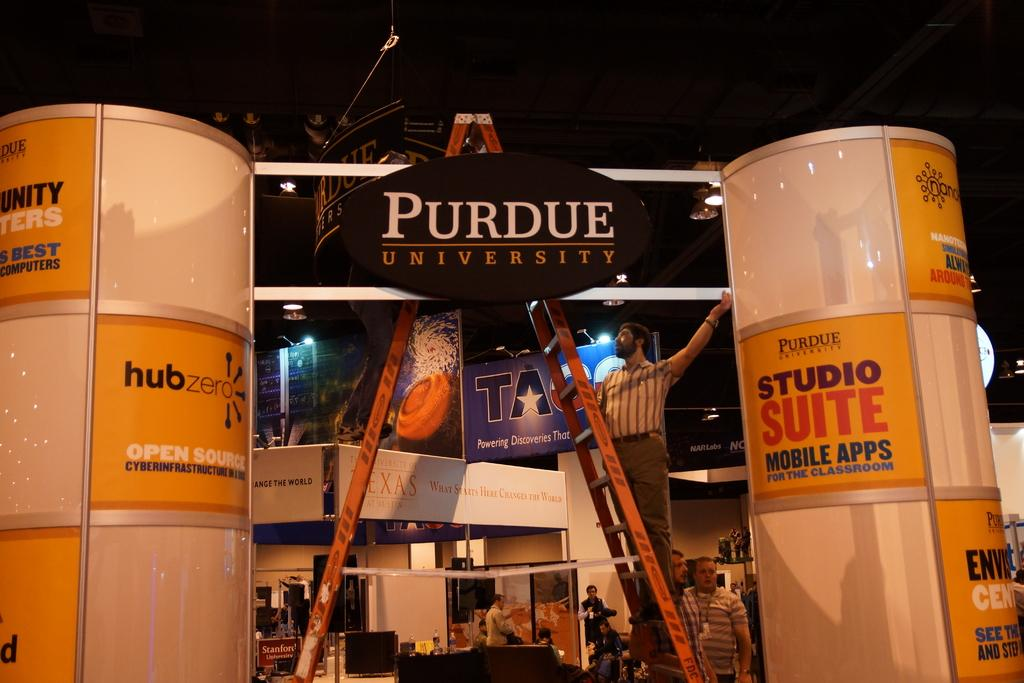How many people are in the image? There are people in the image, but the exact number is not specified. What is one person doing in the image? One person is climbing a ladder in the image. What can be seen in the image that provides illumination? There are lights in the image. What type of objects in the image contain text? There are boards and two cylindrical objects with text in the image. What type of voyage are the pigs embarking on in the image? There are no pigs present in the image, so it is not possible to discuss a voyage involving them. 